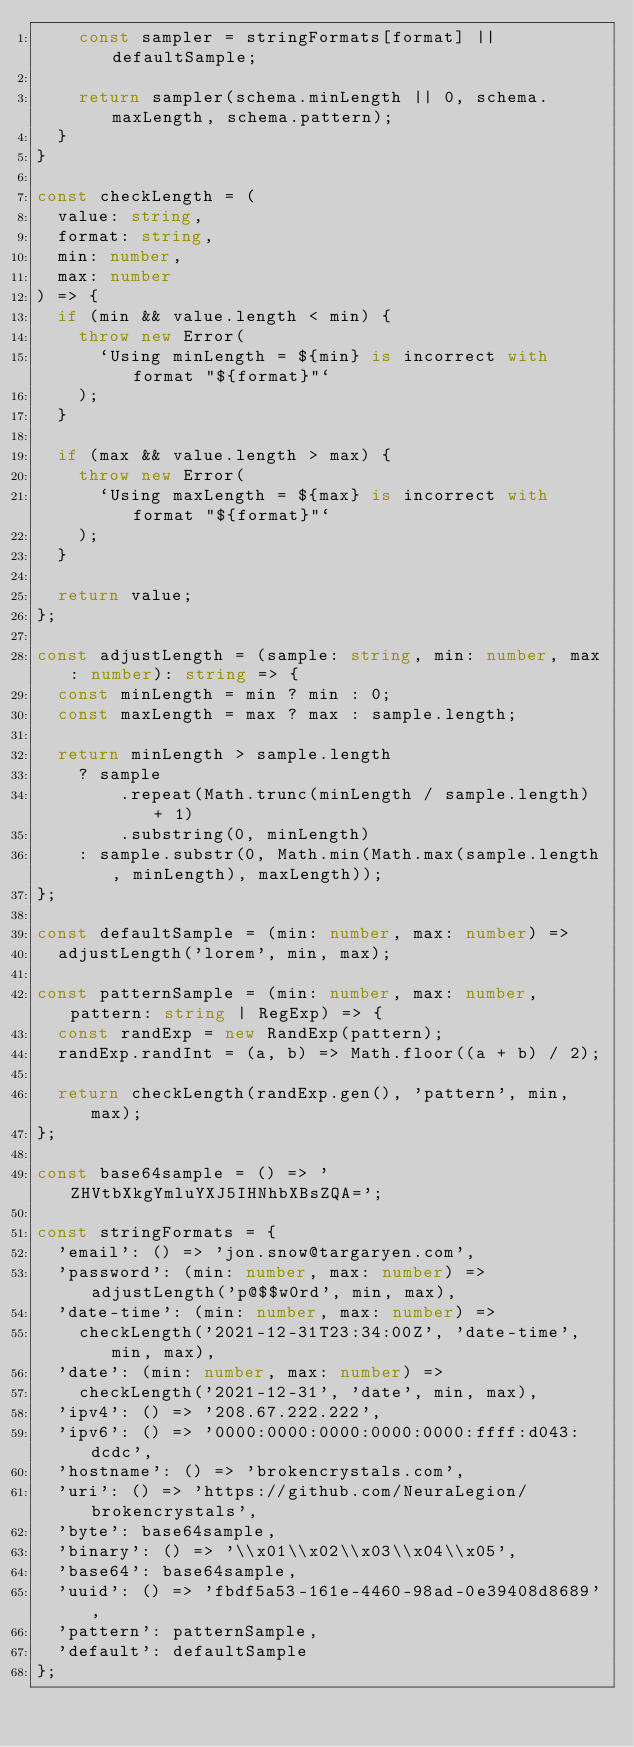<code> <loc_0><loc_0><loc_500><loc_500><_TypeScript_>    const sampler = stringFormats[format] || defaultSample;

    return sampler(schema.minLength || 0, schema.maxLength, schema.pattern);
  }
}

const checkLength = (
  value: string,
  format: string,
  min: number,
  max: number
) => {
  if (min && value.length < min) {
    throw new Error(
      `Using minLength = ${min} is incorrect with format "${format}"`
    );
  }

  if (max && value.length > max) {
    throw new Error(
      `Using maxLength = ${max} is incorrect with format "${format}"`
    );
  }

  return value;
};

const adjustLength = (sample: string, min: number, max: number): string => {
  const minLength = min ? min : 0;
  const maxLength = max ? max : sample.length;

  return minLength > sample.length
    ? sample
        .repeat(Math.trunc(minLength / sample.length) + 1)
        .substring(0, minLength)
    : sample.substr(0, Math.min(Math.max(sample.length, minLength), maxLength));
};

const defaultSample = (min: number, max: number) =>
  adjustLength('lorem', min, max);

const patternSample = (min: number, max: number, pattern: string | RegExp) => {
  const randExp = new RandExp(pattern);
  randExp.randInt = (a, b) => Math.floor((a + b) / 2);

  return checkLength(randExp.gen(), 'pattern', min, max);
};

const base64sample = () => 'ZHVtbXkgYmluYXJ5IHNhbXBsZQA=';

const stringFormats = {
  'email': () => 'jon.snow@targaryen.com',
  'password': (min: number, max: number) => adjustLength('p@$$w0rd', min, max),
  'date-time': (min: number, max: number) =>
    checkLength('2021-12-31T23:34:00Z', 'date-time', min, max),
  'date': (min: number, max: number) =>
    checkLength('2021-12-31', 'date', min, max),
  'ipv4': () => '208.67.222.222',
  'ipv6': () => '0000:0000:0000:0000:0000:ffff:d043:dcdc',
  'hostname': () => 'brokencrystals.com',
  'uri': () => 'https://github.com/NeuraLegion/brokencrystals',
  'byte': base64sample,
  'binary': () => '\\x01\\x02\\x03\\x04\\x05',
  'base64': base64sample,
  'uuid': () => 'fbdf5a53-161e-4460-98ad-0e39408d8689',
  'pattern': patternSample,
  'default': defaultSample
};
</code> 